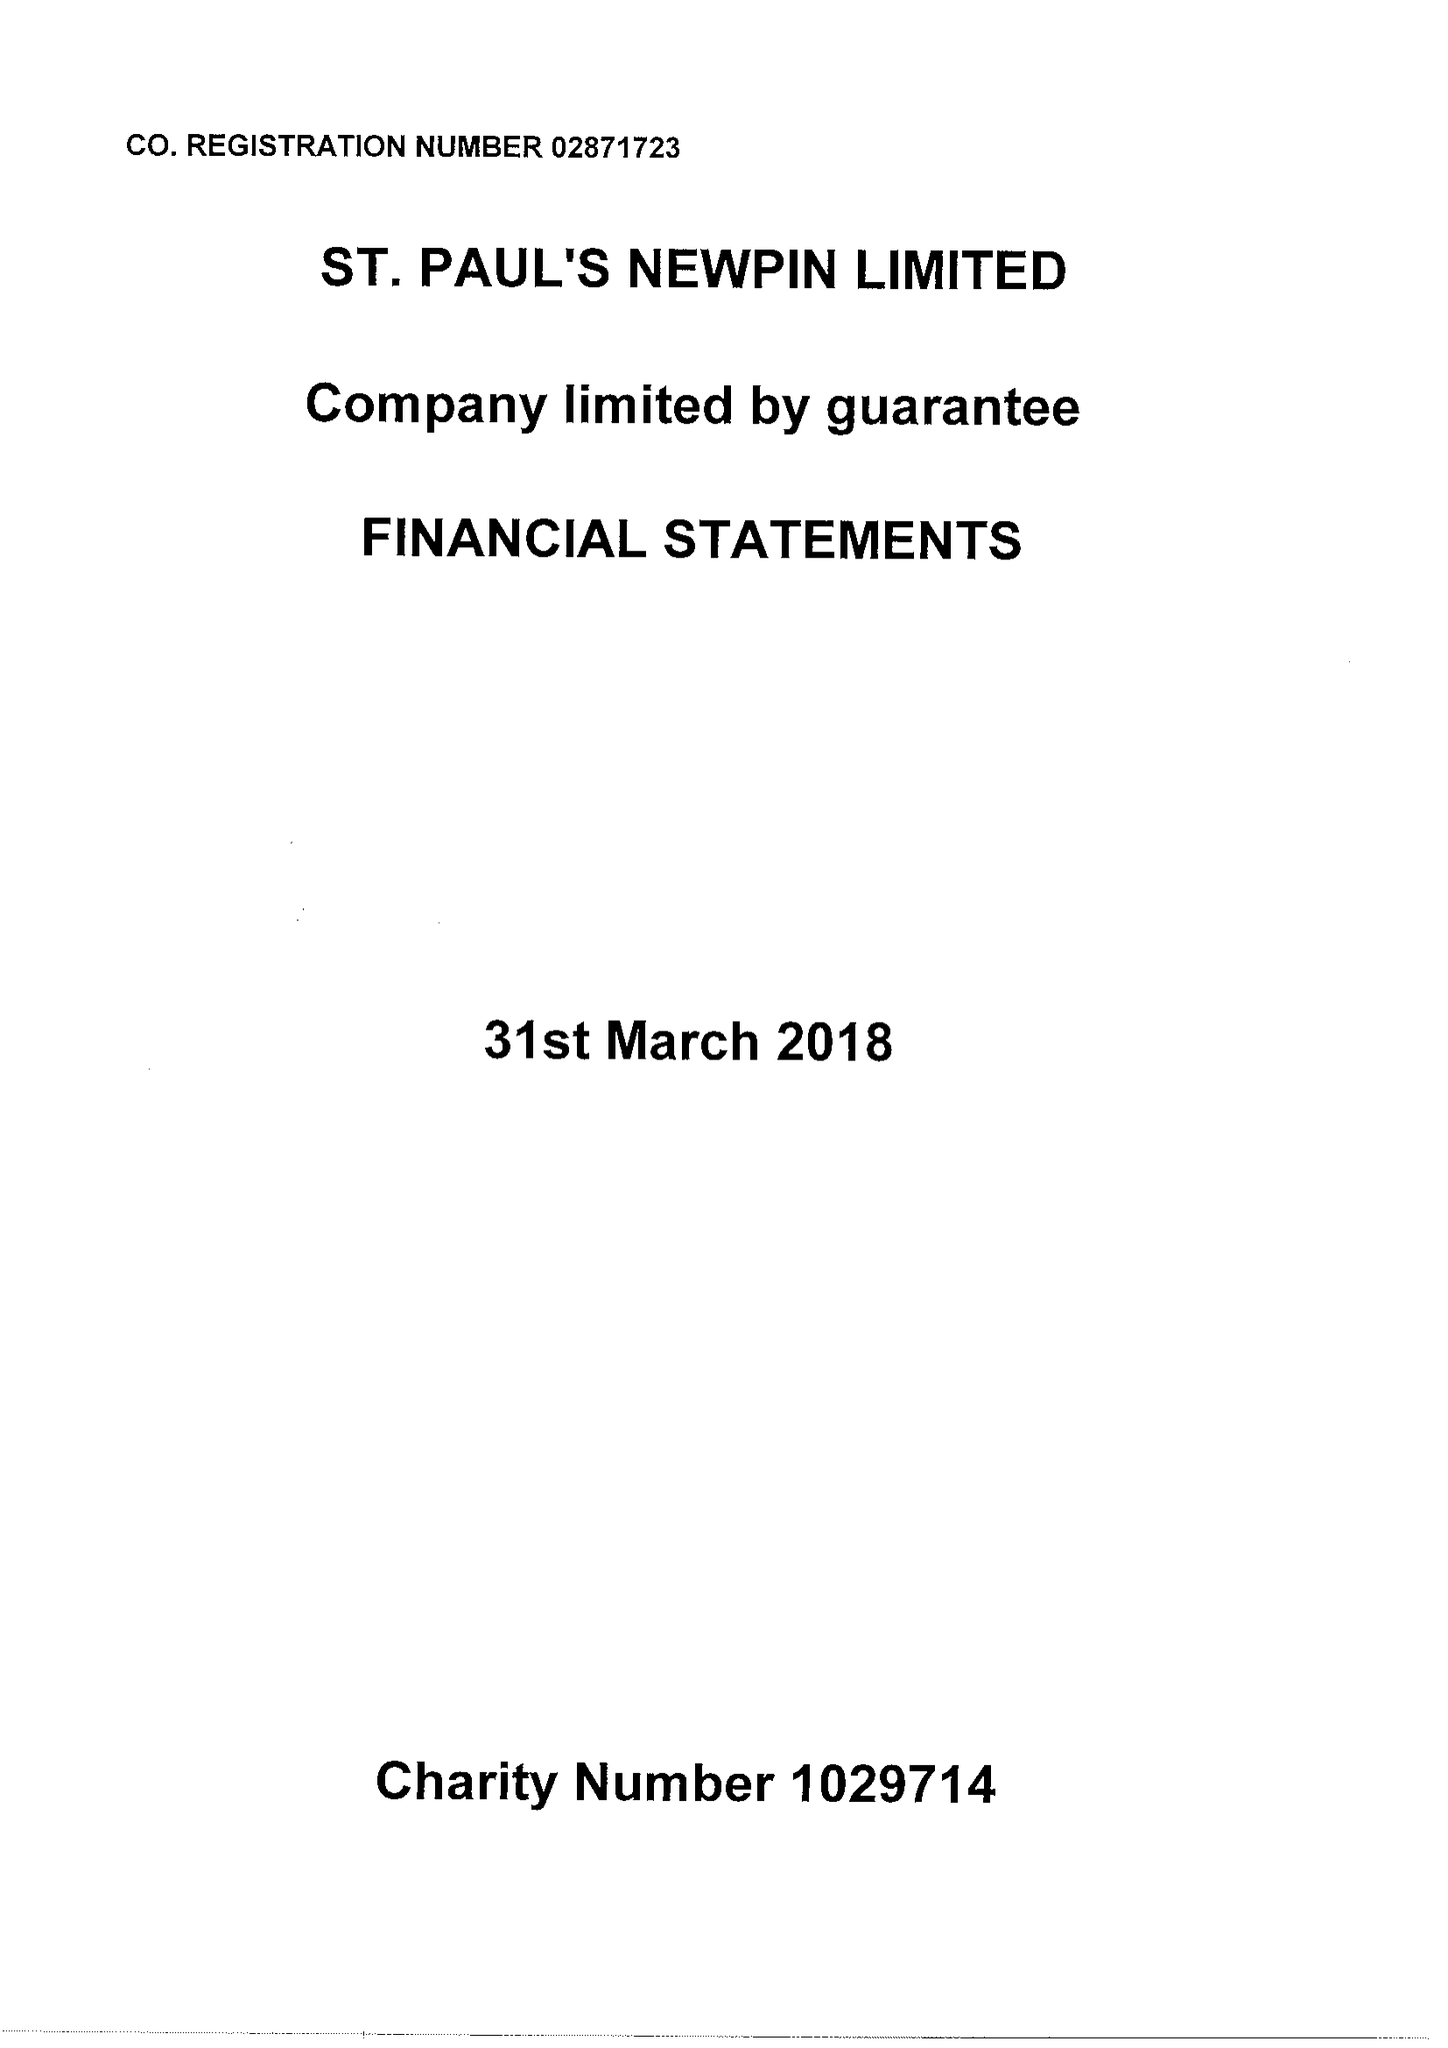What is the value for the spending_annually_in_british_pounds?
Answer the question using a single word or phrase. 109429.00 